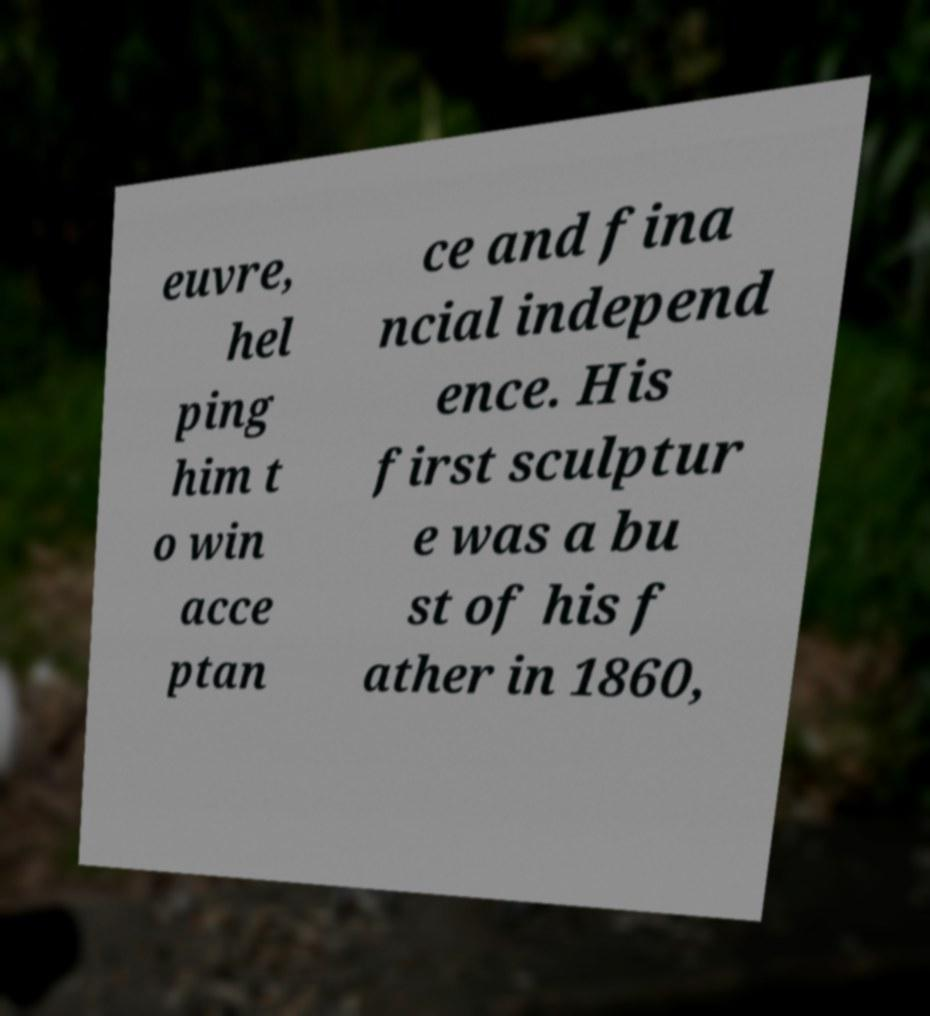There's text embedded in this image that I need extracted. Can you transcribe it verbatim? euvre, hel ping him t o win acce ptan ce and fina ncial independ ence. His first sculptur e was a bu st of his f ather in 1860, 